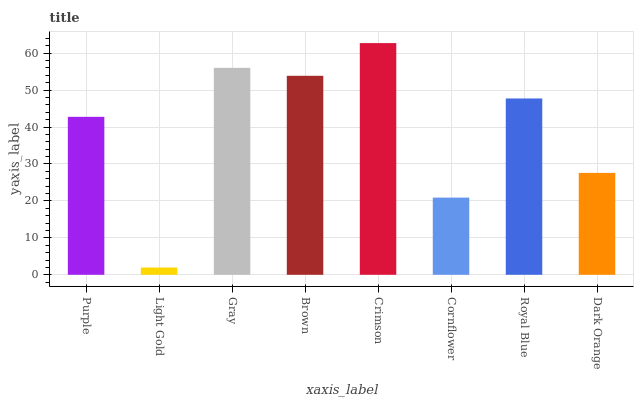Is Light Gold the minimum?
Answer yes or no. Yes. Is Crimson the maximum?
Answer yes or no. Yes. Is Gray the minimum?
Answer yes or no. No. Is Gray the maximum?
Answer yes or no. No. Is Gray greater than Light Gold?
Answer yes or no. Yes. Is Light Gold less than Gray?
Answer yes or no. Yes. Is Light Gold greater than Gray?
Answer yes or no. No. Is Gray less than Light Gold?
Answer yes or no. No. Is Royal Blue the high median?
Answer yes or no. Yes. Is Purple the low median?
Answer yes or no. Yes. Is Dark Orange the high median?
Answer yes or no. No. Is Gray the low median?
Answer yes or no. No. 